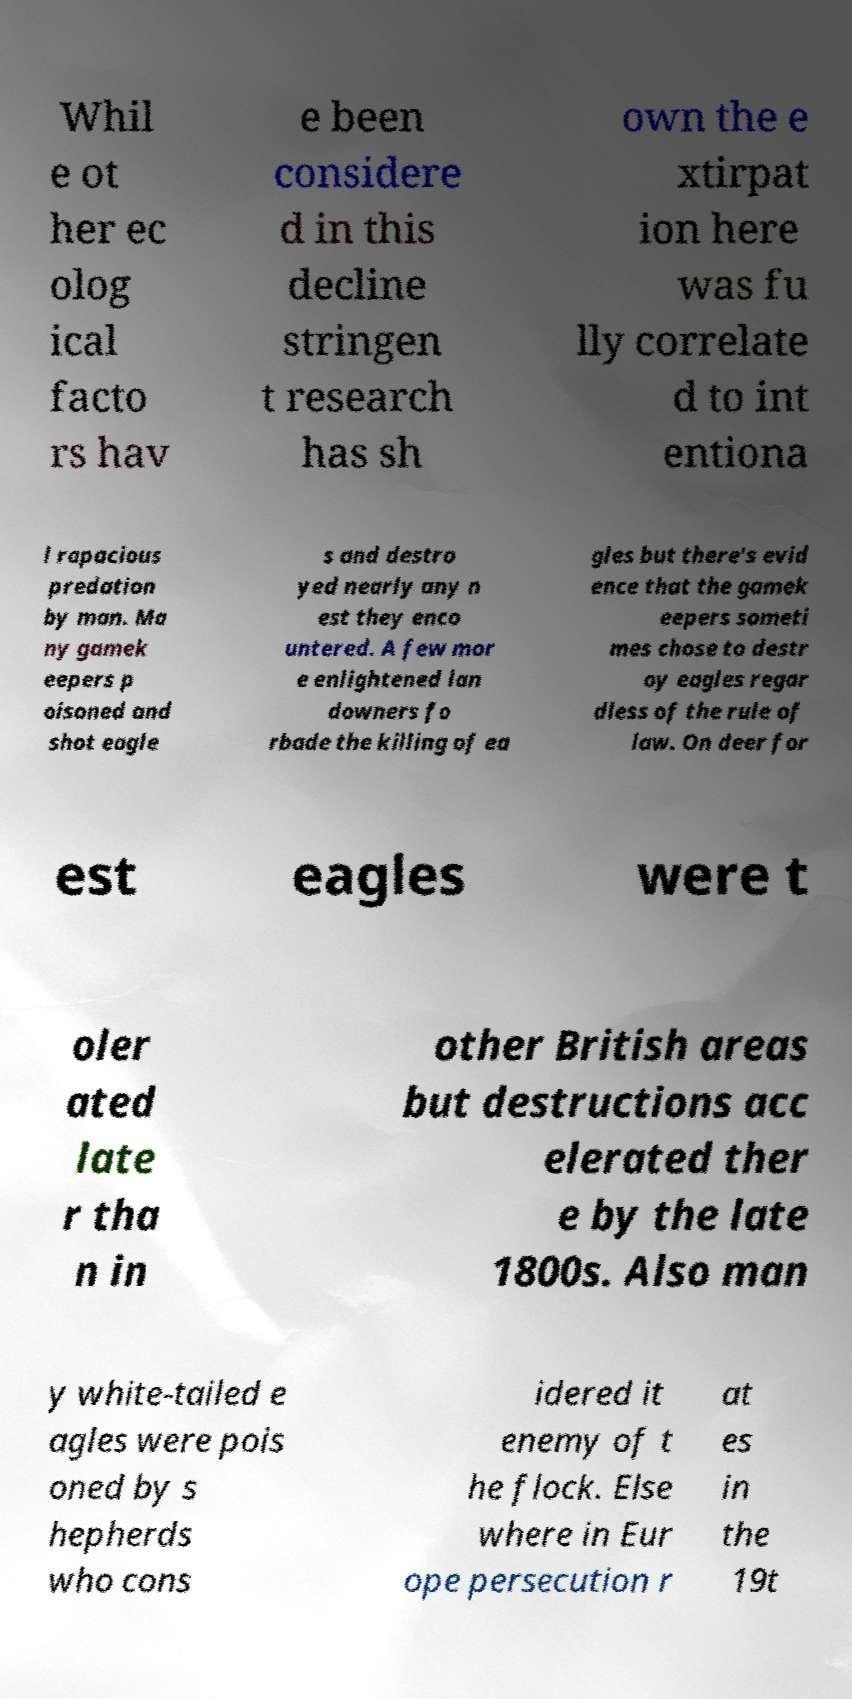Can you accurately transcribe the text from the provided image for me? Whil e ot her ec olog ical facto rs hav e been considere d in this decline stringen t research has sh own the e xtirpat ion here was fu lly correlate d to int entiona l rapacious predation by man. Ma ny gamek eepers p oisoned and shot eagle s and destro yed nearly any n est they enco untered. A few mor e enlightened lan downers fo rbade the killing of ea gles but there's evid ence that the gamek eepers someti mes chose to destr oy eagles regar dless of the rule of law. On deer for est eagles were t oler ated late r tha n in other British areas but destructions acc elerated ther e by the late 1800s. Also man y white-tailed e agles were pois oned by s hepherds who cons idered it enemy of t he flock. Else where in Eur ope persecution r at es in the 19t 